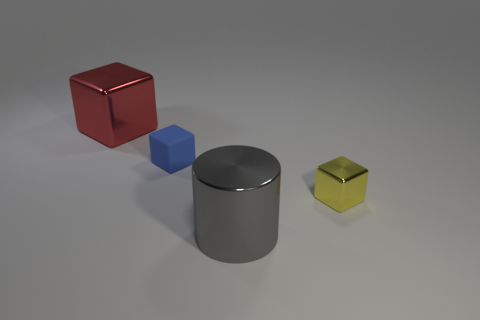Subtract all tiny metallic blocks. How many blocks are left? 2 Add 3 small yellow shiny cylinders. How many objects exist? 7 Subtract all cylinders. How many objects are left? 3 Subtract all yellow blocks. How many blocks are left? 2 Add 3 tiny metal cubes. How many tiny metal cubes are left? 4 Add 4 big purple metal spheres. How many big purple metal spheres exist? 4 Subtract 0 gray spheres. How many objects are left? 4 Subtract 2 blocks. How many blocks are left? 1 Subtract all purple cubes. Subtract all gray spheres. How many cubes are left? 3 Subtract all large shiny cubes. Subtract all matte objects. How many objects are left? 2 